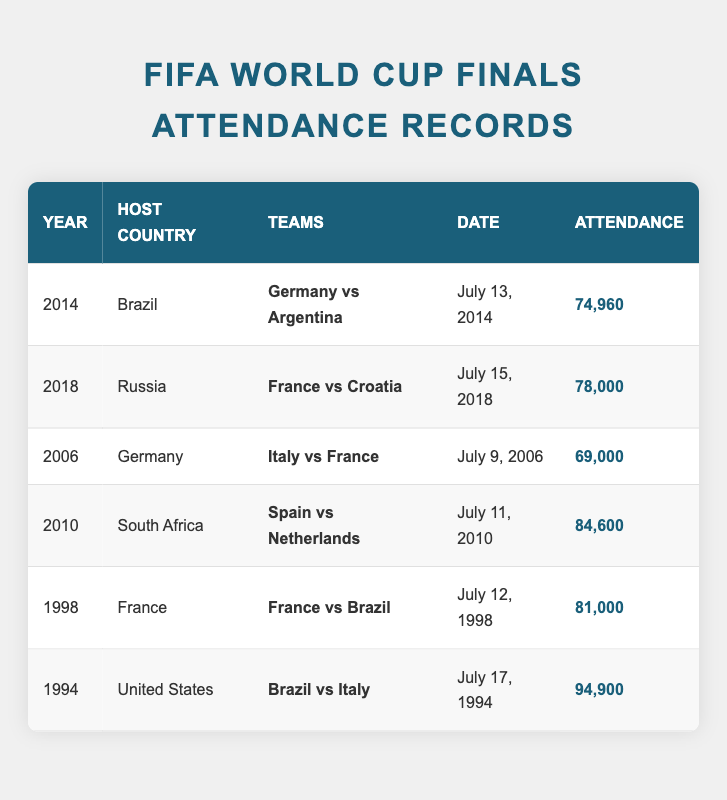What was the attendance at the 2014 World Cup final? The table shows that the attendance at the 2014 World Cup final held in Brazil was 74,960.
Answer: 74,960 Which host country had the highest attendance for a World Cup final? By looking at the table, the highest attendance was recorded in the United States in 1994 at 94,900.
Answer: United States How many teams played in the final matches that had an attendance of over 80,000? The matches with over 80,000 attendance are the finals in 1994 (94,900), 2010 (84,600), and 1998 (81,000), which involved 3 matches with a total of 6 teams: Brazil, Italy, Spain, Netherlands, France, and Croatia.
Answer: 6 teams Did any World Cup final in the 2000s have an attendance less than 70,000? Referring to the years listed, the table shows that the final in 2006 had 69,000 attendance, which is indeed less than 70,000.
Answer: Yes What is the average attendance of the World Cup finals listed in the table? To calculate the average, add the attendances: 74,960 + 78,000 + 69,000 + 84,600 + 81,000 + 94,900 = 482,460. Then divide this sum by 6 (the number of finals listed): 482,460 / 6 ≈ 80,410.
Answer: 80,410 